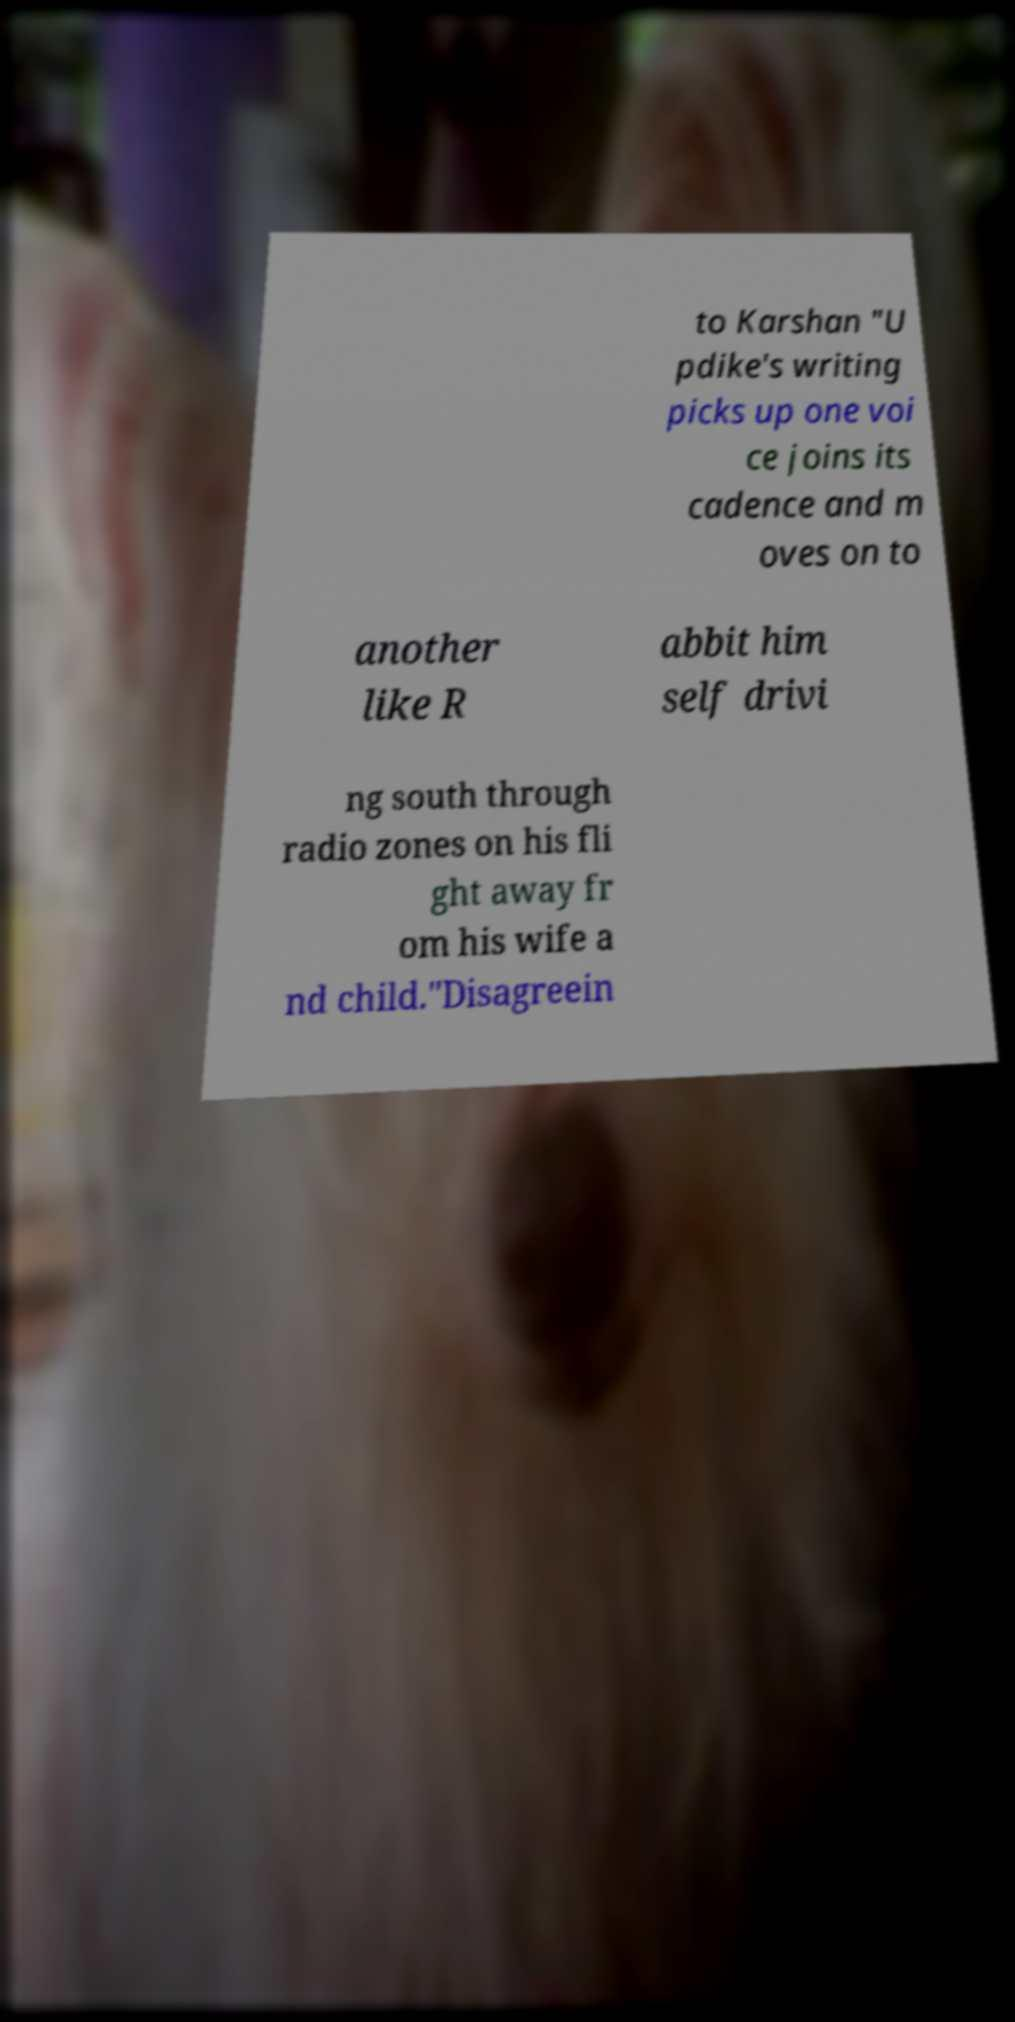Can you accurately transcribe the text from the provided image for me? to Karshan "U pdike's writing picks up one voi ce joins its cadence and m oves on to another like R abbit him self drivi ng south through radio zones on his fli ght away fr om his wife a nd child."Disagreein 